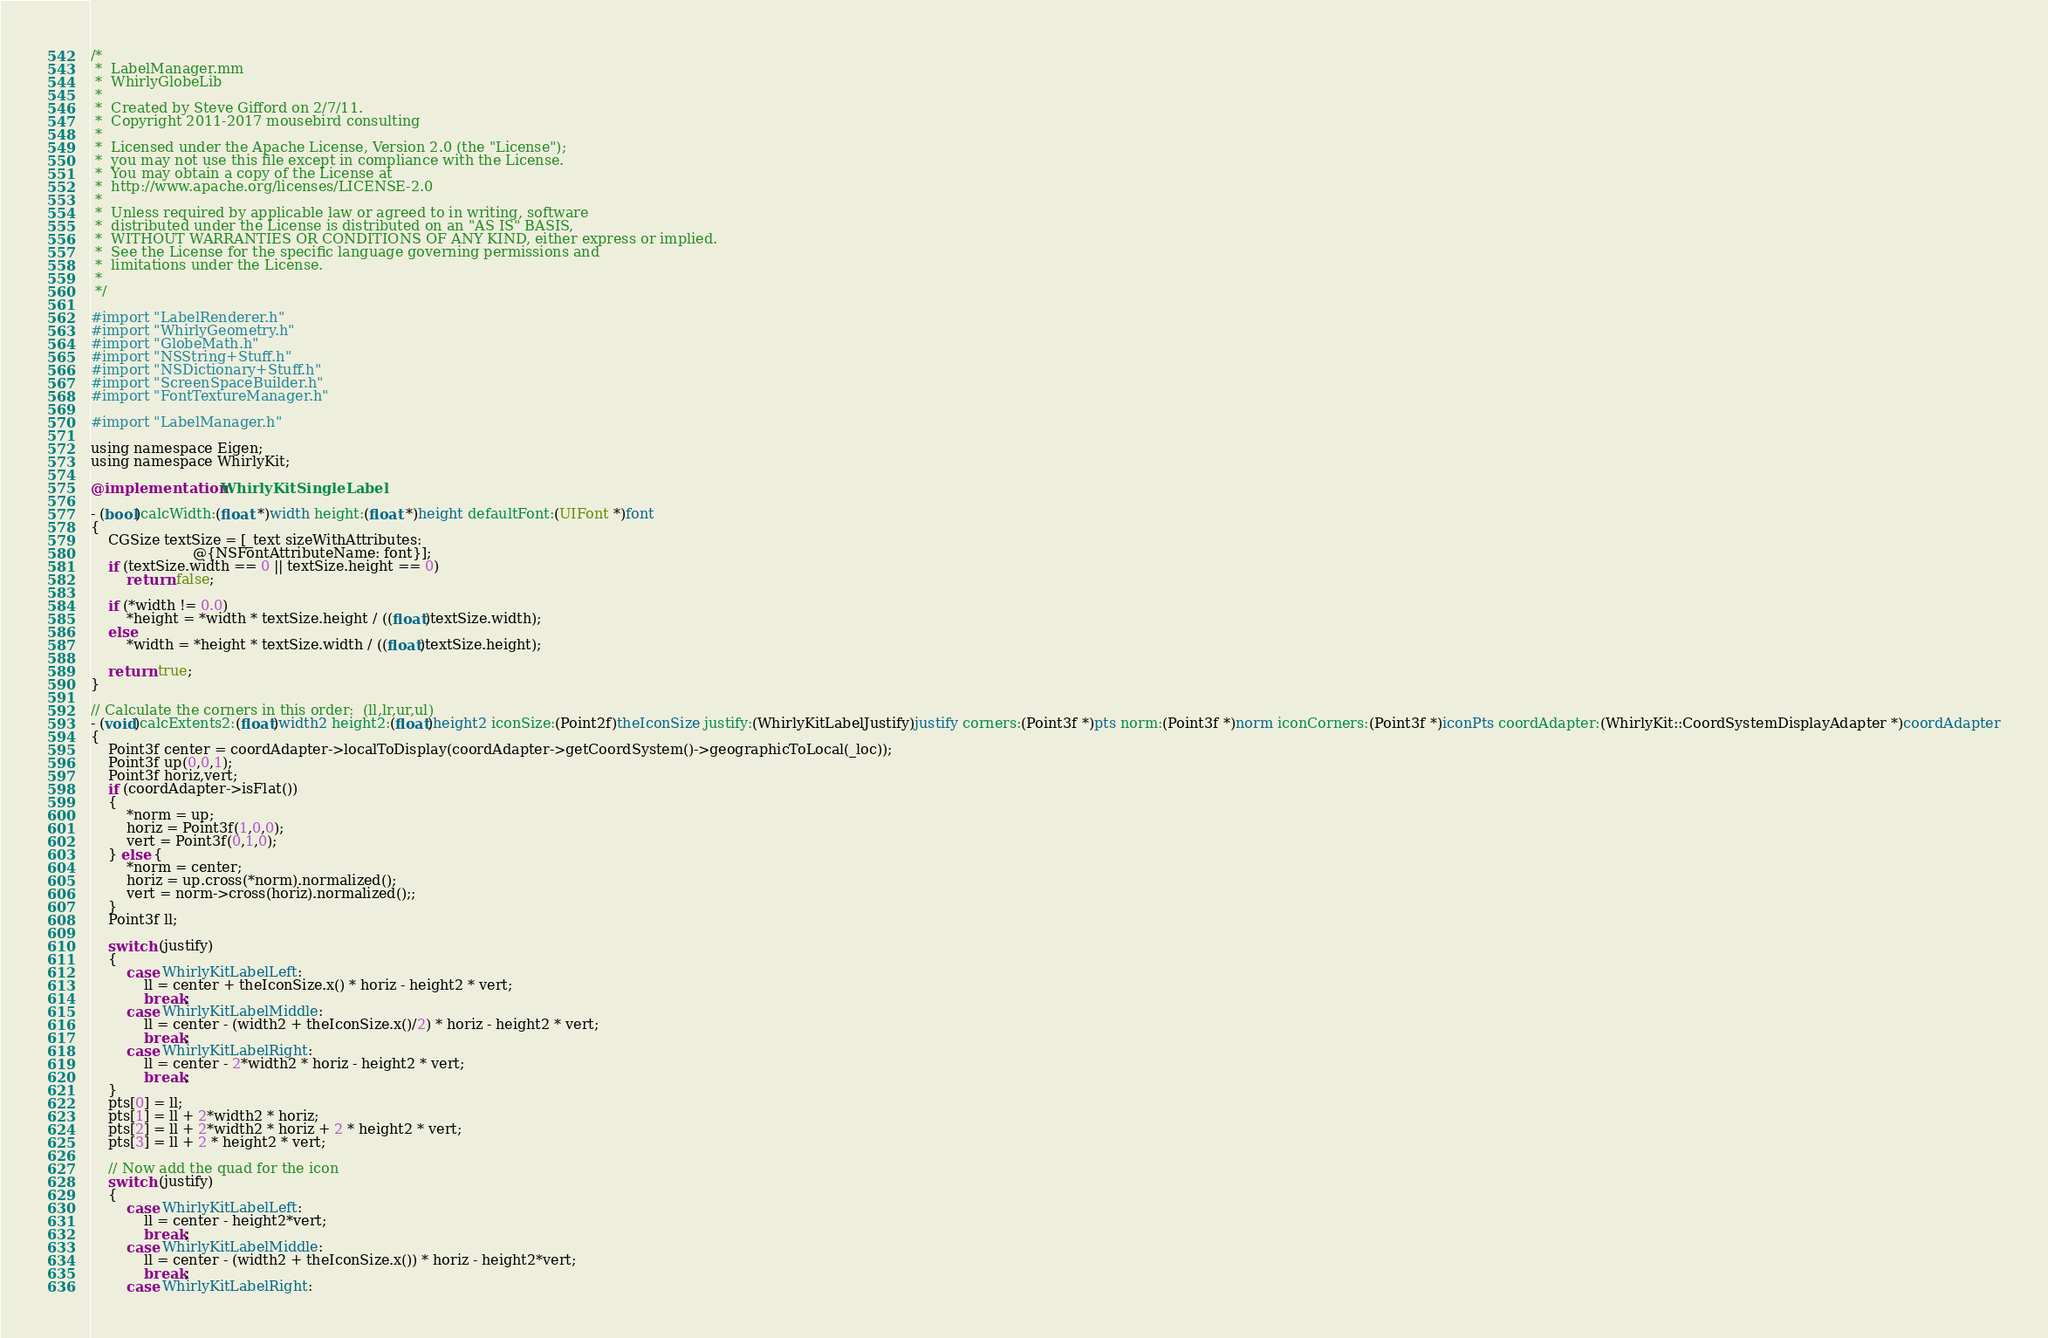Convert code to text. <code><loc_0><loc_0><loc_500><loc_500><_ObjectiveC_>/*
 *  LabelManager.mm
 *  WhirlyGlobeLib
 *
 *  Created by Steve Gifford on 2/7/11.
 *  Copyright 2011-2017 mousebird consulting
 *
 *  Licensed under the Apache License, Version 2.0 (the "License");
 *  you may not use this file except in compliance with the License.
 *  You may obtain a copy of the License at
 *  http://www.apache.org/licenses/LICENSE-2.0
 *
 *  Unless required by applicable law or agreed to in writing, software
 *  distributed under the License is distributed on an "AS IS" BASIS,
 *  WITHOUT WARRANTIES OR CONDITIONS OF ANY KIND, either express or implied.
 *  See the License for the specific language governing permissions and
 *  limitations under the License.
 *
 */

#import "LabelRenderer.h"
#import "WhirlyGeometry.h"
#import "GlobeMath.h"
#import "NSString+Stuff.h"
#import "NSDictionary+Stuff.h"
#import "ScreenSpaceBuilder.h"
#import "FontTextureManager.h"

#import "LabelManager.h"

using namespace Eigen;
using namespace WhirlyKit;

@implementation WhirlyKitSingleLabel

- (bool)calcWidth:(float *)width height:(float *)height defaultFont:(UIFont *)font
{
    CGSize textSize = [_text sizeWithAttributes:
                       @{NSFontAttributeName: font}];
    if (textSize.width == 0 || textSize.height == 0)
        return false;
    
    if (*width != 0.0)
        *height = *width * textSize.height / ((float)textSize.width);
    else
        *width = *height * textSize.width / ((float)textSize.height);
    
    return true;
}

// Calculate the corners in this order:  (ll,lr,ur,ul)
- (void)calcExtents2:(float)width2 height2:(float)height2 iconSize:(Point2f)theIconSize justify:(WhirlyKitLabelJustify)justify corners:(Point3f *)pts norm:(Point3f *)norm iconCorners:(Point3f *)iconPts coordAdapter:(WhirlyKit::CoordSystemDisplayAdapter *)coordAdapter
{
    Point3f center = coordAdapter->localToDisplay(coordAdapter->getCoordSystem()->geographicToLocal(_loc));
    Point3f up(0,0,1);
    Point3f horiz,vert;
    if (coordAdapter->isFlat())
    {
        *norm = up;
        horiz = Point3f(1,0,0);
        vert = Point3f(0,1,0);
    } else {
        *norm = center;
        horiz = up.cross(*norm).normalized();
        vert = norm->cross(horiz).normalized();;
    }
    Point3f ll;
    
    switch (justify)
    {
        case WhirlyKitLabelLeft:
            ll = center + theIconSize.x() * horiz - height2 * vert;
            break;
        case WhirlyKitLabelMiddle:
            ll = center - (width2 + theIconSize.x()/2) * horiz - height2 * vert;
            break;
        case WhirlyKitLabelRight:
            ll = center - 2*width2 * horiz - height2 * vert;
            break;
    }
    pts[0] = ll;
    pts[1] = ll + 2*width2 * horiz;
    pts[2] = ll + 2*width2 * horiz + 2 * height2 * vert;
    pts[3] = ll + 2 * height2 * vert;
    
    // Now add the quad for the icon
    switch (justify)
    {
        case WhirlyKitLabelLeft:
            ll = center - height2*vert;
            break;
        case WhirlyKitLabelMiddle:
            ll = center - (width2 + theIconSize.x()) * horiz - height2*vert;
            break;
        case WhirlyKitLabelRight:</code> 